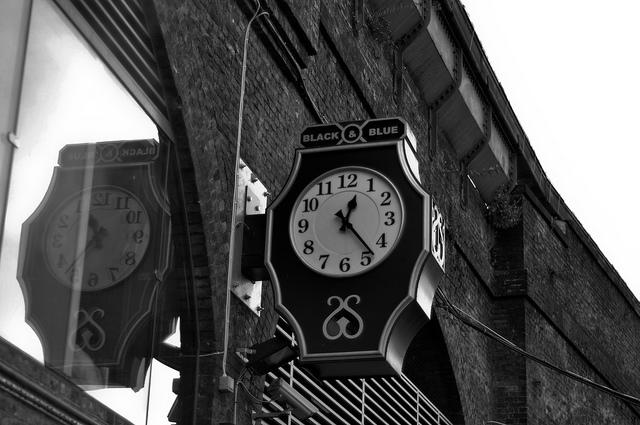What time is it on this clock?
Give a very brief answer. 12:24. What color is the photo?
Short answer required. Black and white. What is the symbol on the bottom half o the clock?
Concise answer only. Heart. 